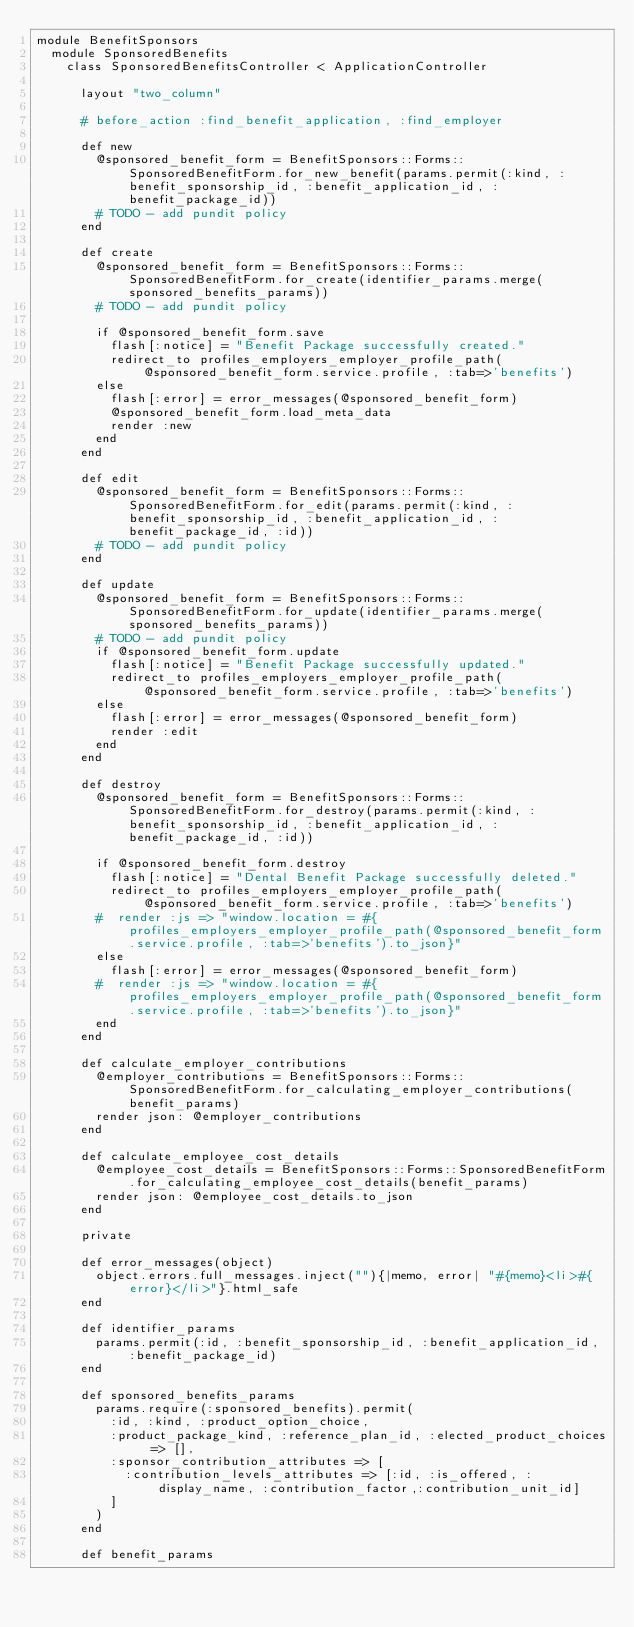<code> <loc_0><loc_0><loc_500><loc_500><_Ruby_>module BenefitSponsors
  module SponsoredBenefits
    class SponsoredBenefitsController < ApplicationController
      
      layout "two_column"

      # before_action :find_benefit_application, :find_employer

      def new
        @sponsored_benefit_form = BenefitSponsors::Forms::SponsoredBenefitForm.for_new_benefit(params.permit(:kind, :benefit_sponsorship_id, :benefit_application_id, :benefit_package_id))
        # TODO - add pundit policy
      end

      def create
        @sponsored_benefit_form = BenefitSponsors::Forms::SponsoredBenefitForm.for_create(identifier_params.merge(sponsored_benefits_params))
        # TODO - add pundit policy

        if @sponsored_benefit_form.save
          flash[:notice] = "Benefit Package successfully created."
          redirect_to profiles_employers_employer_profile_path(@sponsored_benefit_form.service.profile, :tab=>'benefits')
        else
          flash[:error] = error_messages(@sponsored_benefit_form)
          @sponsored_benefit_form.load_meta_data
          render :new
        end
      end

      def edit
        @sponsored_benefit_form = BenefitSponsors::Forms::SponsoredBenefitForm.for_edit(params.permit(:kind, :benefit_sponsorship_id, :benefit_application_id, :benefit_package_id, :id))
        # TODO - add pundit policy
      end

      def update
        @sponsored_benefit_form = BenefitSponsors::Forms::SponsoredBenefitForm.for_update(identifier_params.merge(sponsored_benefits_params))
        # TODO - add pundit policy
        if @sponsored_benefit_form.update
          flash[:notice] = "Benefit Package successfully updated."
          redirect_to profiles_employers_employer_profile_path(@sponsored_benefit_form.service.profile, :tab=>'benefits')
        else
          flash[:error] = error_messages(@sponsored_benefit_form)
          render :edit
        end
      end

      def destroy
        @sponsored_benefit_form = BenefitSponsors::Forms::SponsoredBenefitForm.for_destroy(params.permit(:kind, :benefit_sponsorship_id, :benefit_application_id, :benefit_package_id, :id))

        if @sponsored_benefit_form.destroy
          flash[:notice] = "Dental Benefit Package successfully deleted."
          redirect_to profiles_employers_employer_profile_path(@sponsored_benefit_form.service.profile, :tab=>'benefits')
        #  render :js => "window.location = #{profiles_employers_employer_profile_path(@sponsored_benefit_form.service.profile, :tab=>'benefits').to_json}"
        else
          flash[:error] = error_messages(@sponsored_benefit_form)
        #  render :js => "window.location = #{profiles_employers_employer_profile_path(@sponsored_benefit_form.service.profile, :tab=>'benefits').to_json}"
        end
      end

      def calculate_employer_contributions
        @employer_contributions = BenefitSponsors::Forms::SponsoredBenefitForm.for_calculating_employer_contributions(benefit_params)
        render json: @employer_contributions
      end

      def calculate_employee_cost_details
        @employee_cost_details = BenefitSponsors::Forms::SponsoredBenefitForm.for_calculating_employee_cost_details(benefit_params)
        render json: @employee_cost_details.to_json
      end

      private

      def error_messages(object)
        object.errors.full_messages.inject(""){|memo, error| "#{memo}<li>#{error}</li>"}.html_safe
      end

      def identifier_params
        params.permit(:id, :benefit_sponsorship_id, :benefit_application_id, :benefit_package_id)
      end

      def sponsored_benefits_params
        params.require(:sponsored_benefits).permit(
          :id, :kind, :product_option_choice,
          :product_package_kind, :reference_plan_id, :elected_product_choices => [],
          :sponsor_contribution_attributes => [
            :contribution_levels_attributes => [:id, :is_offered, :display_name, :contribution_factor,:contribution_unit_id]
          ]
        )
      end

      def benefit_params</code> 